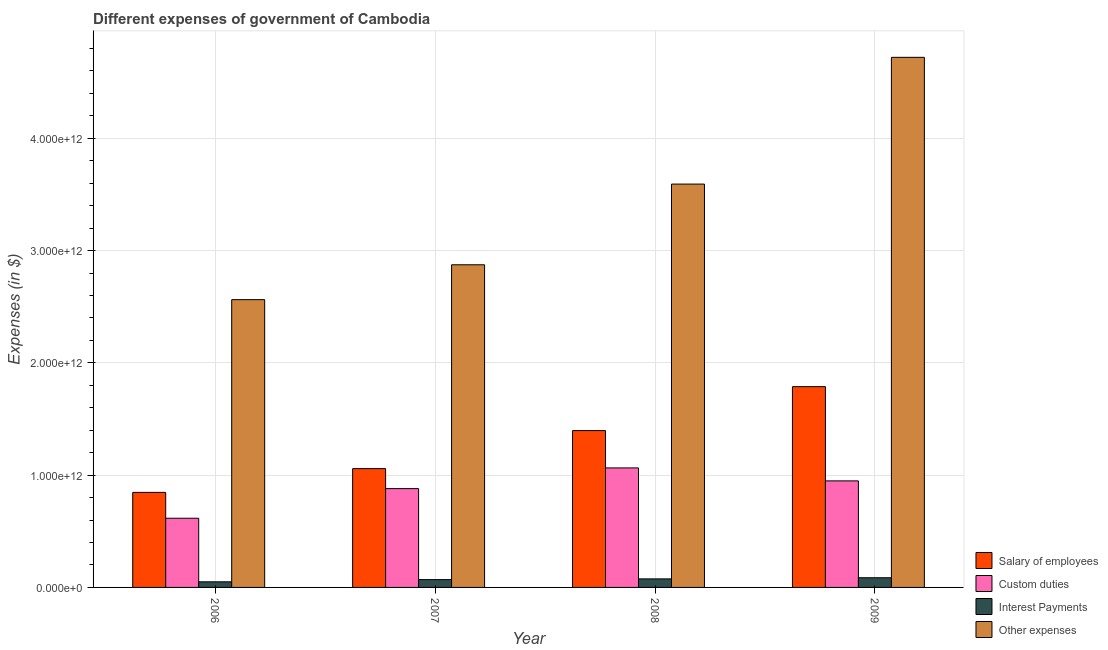How many groups of bars are there?
Your answer should be very brief. 4. Are the number of bars per tick equal to the number of legend labels?
Your answer should be very brief. Yes. Are the number of bars on each tick of the X-axis equal?
Your response must be concise. Yes. How many bars are there on the 1st tick from the right?
Offer a very short reply. 4. What is the label of the 1st group of bars from the left?
Your answer should be very brief. 2006. What is the amount spent on salary of employees in 2006?
Provide a short and direct response. 8.47e+11. Across all years, what is the maximum amount spent on interest payments?
Keep it short and to the point. 8.63e+1. Across all years, what is the minimum amount spent on interest payments?
Make the answer very short. 5.00e+1. In which year was the amount spent on custom duties maximum?
Ensure brevity in your answer.  2008. In which year was the amount spent on salary of employees minimum?
Offer a terse response. 2006. What is the total amount spent on interest payments in the graph?
Keep it short and to the point. 2.82e+11. What is the difference between the amount spent on salary of employees in 2006 and that in 2007?
Offer a very short reply. -2.12e+11. What is the difference between the amount spent on other expenses in 2009 and the amount spent on custom duties in 2006?
Give a very brief answer. 2.16e+12. What is the average amount spent on custom duties per year?
Give a very brief answer. 8.77e+11. What is the ratio of the amount spent on interest payments in 2007 to that in 2009?
Make the answer very short. 0.81. Is the amount spent on interest payments in 2006 less than that in 2009?
Your response must be concise. Yes. Is the difference between the amount spent on salary of employees in 2007 and 2009 greater than the difference between the amount spent on interest payments in 2007 and 2009?
Provide a short and direct response. No. What is the difference between the highest and the second highest amount spent on custom duties?
Keep it short and to the point. 1.15e+11. What is the difference between the highest and the lowest amount spent on custom duties?
Give a very brief answer. 4.48e+11. In how many years, is the amount spent on interest payments greater than the average amount spent on interest payments taken over all years?
Ensure brevity in your answer.  2. Is the sum of the amount spent on salary of employees in 2007 and 2008 greater than the maximum amount spent on custom duties across all years?
Ensure brevity in your answer.  Yes. What does the 2nd bar from the left in 2009 represents?
Keep it short and to the point. Custom duties. What does the 3rd bar from the right in 2008 represents?
Keep it short and to the point. Custom duties. How many bars are there?
Give a very brief answer. 16. How many years are there in the graph?
Keep it short and to the point. 4. What is the difference between two consecutive major ticks on the Y-axis?
Provide a succinct answer. 1.00e+12. Does the graph contain any zero values?
Ensure brevity in your answer.  No. Does the graph contain grids?
Give a very brief answer. Yes. What is the title of the graph?
Ensure brevity in your answer.  Different expenses of government of Cambodia. What is the label or title of the X-axis?
Provide a succinct answer. Year. What is the label or title of the Y-axis?
Offer a terse response. Expenses (in $). What is the Expenses (in $) of Salary of employees in 2006?
Ensure brevity in your answer.  8.47e+11. What is the Expenses (in $) in Custom duties in 2006?
Your answer should be compact. 6.16e+11. What is the Expenses (in $) in Interest Payments in 2006?
Give a very brief answer. 5.00e+1. What is the Expenses (in $) of Other expenses in 2006?
Your answer should be compact. 2.56e+12. What is the Expenses (in $) in Salary of employees in 2007?
Provide a short and direct response. 1.06e+12. What is the Expenses (in $) in Custom duties in 2007?
Make the answer very short. 8.80e+11. What is the Expenses (in $) in Interest Payments in 2007?
Offer a very short reply. 6.97e+1. What is the Expenses (in $) in Other expenses in 2007?
Make the answer very short. 2.87e+12. What is the Expenses (in $) of Salary of employees in 2008?
Ensure brevity in your answer.  1.40e+12. What is the Expenses (in $) in Custom duties in 2008?
Give a very brief answer. 1.06e+12. What is the Expenses (in $) of Interest Payments in 2008?
Ensure brevity in your answer.  7.61e+1. What is the Expenses (in $) of Other expenses in 2008?
Give a very brief answer. 3.59e+12. What is the Expenses (in $) in Salary of employees in 2009?
Your answer should be very brief. 1.79e+12. What is the Expenses (in $) in Custom duties in 2009?
Make the answer very short. 9.49e+11. What is the Expenses (in $) in Interest Payments in 2009?
Make the answer very short. 8.63e+1. What is the Expenses (in $) of Other expenses in 2009?
Offer a terse response. 4.72e+12. Across all years, what is the maximum Expenses (in $) of Salary of employees?
Make the answer very short. 1.79e+12. Across all years, what is the maximum Expenses (in $) in Custom duties?
Provide a short and direct response. 1.06e+12. Across all years, what is the maximum Expenses (in $) of Interest Payments?
Provide a short and direct response. 8.63e+1. Across all years, what is the maximum Expenses (in $) of Other expenses?
Provide a short and direct response. 4.72e+12. Across all years, what is the minimum Expenses (in $) in Salary of employees?
Offer a very short reply. 8.47e+11. Across all years, what is the minimum Expenses (in $) of Custom duties?
Keep it short and to the point. 6.16e+11. Across all years, what is the minimum Expenses (in $) in Interest Payments?
Your response must be concise. 5.00e+1. Across all years, what is the minimum Expenses (in $) in Other expenses?
Your answer should be compact. 2.56e+12. What is the total Expenses (in $) in Salary of employees in the graph?
Your answer should be compact. 5.09e+12. What is the total Expenses (in $) in Custom duties in the graph?
Give a very brief answer. 3.51e+12. What is the total Expenses (in $) in Interest Payments in the graph?
Offer a terse response. 2.82e+11. What is the total Expenses (in $) of Other expenses in the graph?
Offer a terse response. 1.38e+13. What is the difference between the Expenses (in $) of Salary of employees in 2006 and that in 2007?
Your answer should be compact. -2.12e+11. What is the difference between the Expenses (in $) of Custom duties in 2006 and that in 2007?
Provide a succinct answer. -2.64e+11. What is the difference between the Expenses (in $) of Interest Payments in 2006 and that in 2007?
Ensure brevity in your answer.  -1.97e+1. What is the difference between the Expenses (in $) of Other expenses in 2006 and that in 2007?
Your answer should be compact. -3.11e+11. What is the difference between the Expenses (in $) in Salary of employees in 2006 and that in 2008?
Provide a short and direct response. -5.50e+11. What is the difference between the Expenses (in $) in Custom duties in 2006 and that in 2008?
Offer a very short reply. -4.48e+11. What is the difference between the Expenses (in $) in Interest Payments in 2006 and that in 2008?
Offer a terse response. -2.61e+1. What is the difference between the Expenses (in $) of Other expenses in 2006 and that in 2008?
Provide a short and direct response. -1.03e+12. What is the difference between the Expenses (in $) of Salary of employees in 2006 and that in 2009?
Offer a very short reply. -9.42e+11. What is the difference between the Expenses (in $) of Custom duties in 2006 and that in 2009?
Provide a succinct answer. -3.33e+11. What is the difference between the Expenses (in $) of Interest Payments in 2006 and that in 2009?
Give a very brief answer. -3.63e+1. What is the difference between the Expenses (in $) in Other expenses in 2006 and that in 2009?
Provide a succinct answer. -2.16e+12. What is the difference between the Expenses (in $) of Salary of employees in 2007 and that in 2008?
Ensure brevity in your answer.  -3.39e+11. What is the difference between the Expenses (in $) of Custom duties in 2007 and that in 2008?
Keep it short and to the point. -1.84e+11. What is the difference between the Expenses (in $) in Interest Payments in 2007 and that in 2008?
Your answer should be very brief. -6.34e+09. What is the difference between the Expenses (in $) in Other expenses in 2007 and that in 2008?
Provide a succinct answer. -7.19e+11. What is the difference between the Expenses (in $) of Salary of employees in 2007 and that in 2009?
Ensure brevity in your answer.  -7.30e+11. What is the difference between the Expenses (in $) of Custom duties in 2007 and that in 2009?
Your answer should be very brief. -6.90e+1. What is the difference between the Expenses (in $) in Interest Payments in 2007 and that in 2009?
Offer a very short reply. -1.66e+1. What is the difference between the Expenses (in $) in Other expenses in 2007 and that in 2009?
Keep it short and to the point. -1.85e+12. What is the difference between the Expenses (in $) in Salary of employees in 2008 and that in 2009?
Give a very brief answer. -3.91e+11. What is the difference between the Expenses (in $) of Custom duties in 2008 and that in 2009?
Make the answer very short. 1.15e+11. What is the difference between the Expenses (in $) of Interest Payments in 2008 and that in 2009?
Offer a very short reply. -1.02e+1. What is the difference between the Expenses (in $) in Other expenses in 2008 and that in 2009?
Your answer should be compact. -1.13e+12. What is the difference between the Expenses (in $) of Salary of employees in 2006 and the Expenses (in $) of Custom duties in 2007?
Ensure brevity in your answer.  -3.35e+1. What is the difference between the Expenses (in $) of Salary of employees in 2006 and the Expenses (in $) of Interest Payments in 2007?
Provide a succinct answer. 7.77e+11. What is the difference between the Expenses (in $) of Salary of employees in 2006 and the Expenses (in $) of Other expenses in 2007?
Ensure brevity in your answer.  -2.03e+12. What is the difference between the Expenses (in $) of Custom duties in 2006 and the Expenses (in $) of Interest Payments in 2007?
Offer a terse response. 5.47e+11. What is the difference between the Expenses (in $) of Custom duties in 2006 and the Expenses (in $) of Other expenses in 2007?
Provide a succinct answer. -2.26e+12. What is the difference between the Expenses (in $) in Interest Payments in 2006 and the Expenses (in $) in Other expenses in 2007?
Offer a terse response. -2.82e+12. What is the difference between the Expenses (in $) in Salary of employees in 2006 and the Expenses (in $) in Custom duties in 2008?
Your answer should be compact. -2.18e+11. What is the difference between the Expenses (in $) of Salary of employees in 2006 and the Expenses (in $) of Interest Payments in 2008?
Ensure brevity in your answer.  7.71e+11. What is the difference between the Expenses (in $) of Salary of employees in 2006 and the Expenses (in $) of Other expenses in 2008?
Your answer should be compact. -2.75e+12. What is the difference between the Expenses (in $) of Custom duties in 2006 and the Expenses (in $) of Interest Payments in 2008?
Offer a terse response. 5.40e+11. What is the difference between the Expenses (in $) of Custom duties in 2006 and the Expenses (in $) of Other expenses in 2008?
Make the answer very short. -2.98e+12. What is the difference between the Expenses (in $) in Interest Payments in 2006 and the Expenses (in $) in Other expenses in 2008?
Offer a terse response. -3.54e+12. What is the difference between the Expenses (in $) in Salary of employees in 2006 and the Expenses (in $) in Custom duties in 2009?
Make the answer very short. -1.02e+11. What is the difference between the Expenses (in $) in Salary of employees in 2006 and the Expenses (in $) in Interest Payments in 2009?
Keep it short and to the point. 7.60e+11. What is the difference between the Expenses (in $) in Salary of employees in 2006 and the Expenses (in $) in Other expenses in 2009?
Ensure brevity in your answer.  -3.87e+12. What is the difference between the Expenses (in $) in Custom duties in 2006 and the Expenses (in $) in Interest Payments in 2009?
Ensure brevity in your answer.  5.30e+11. What is the difference between the Expenses (in $) of Custom duties in 2006 and the Expenses (in $) of Other expenses in 2009?
Offer a terse response. -4.11e+12. What is the difference between the Expenses (in $) in Interest Payments in 2006 and the Expenses (in $) in Other expenses in 2009?
Your answer should be very brief. -4.67e+12. What is the difference between the Expenses (in $) of Salary of employees in 2007 and the Expenses (in $) of Custom duties in 2008?
Offer a terse response. -6.22e+09. What is the difference between the Expenses (in $) in Salary of employees in 2007 and the Expenses (in $) in Interest Payments in 2008?
Offer a terse response. 9.82e+11. What is the difference between the Expenses (in $) in Salary of employees in 2007 and the Expenses (in $) in Other expenses in 2008?
Offer a very short reply. -2.53e+12. What is the difference between the Expenses (in $) of Custom duties in 2007 and the Expenses (in $) of Interest Payments in 2008?
Provide a short and direct response. 8.04e+11. What is the difference between the Expenses (in $) in Custom duties in 2007 and the Expenses (in $) in Other expenses in 2008?
Offer a terse response. -2.71e+12. What is the difference between the Expenses (in $) in Interest Payments in 2007 and the Expenses (in $) in Other expenses in 2008?
Make the answer very short. -3.52e+12. What is the difference between the Expenses (in $) in Salary of employees in 2007 and the Expenses (in $) in Custom duties in 2009?
Ensure brevity in your answer.  1.09e+11. What is the difference between the Expenses (in $) in Salary of employees in 2007 and the Expenses (in $) in Interest Payments in 2009?
Ensure brevity in your answer.  9.72e+11. What is the difference between the Expenses (in $) of Salary of employees in 2007 and the Expenses (in $) of Other expenses in 2009?
Your answer should be compact. -3.66e+12. What is the difference between the Expenses (in $) of Custom duties in 2007 and the Expenses (in $) of Interest Payments in 2009?
Provide a short and direct response. 7.94e+11. What is the difference between the Expenses (in $) in Custom duties in 2007 and the Expenses (in $) in Other expenses in 2009?
Make the answer very short. -3.84e+12. What is the difference between the Expenses (in $) in Interest Payments in 2007 and the Expenses (in $) in Other expenses in 2009?
Give a very brief answer. -4.65e+12. What is the difference between the Expenses (in $) of Salary of employees in 2008 and the Expenses (in $) of Custom duties in 2009?
Keep it short and to the point. 4.48e+11. What is the difference between the Expenses (in $) of Salary of employees in 2008 and the Expenses (in $) of Interest Payments in 2009?
Your answer should be compact. 1.31e+12. What is the difference between the Expenses (in $) of Salary of employees in 2008 and the Expenses (in $) of Other expenses in 2009?
Provide a succinct answer. -3.32e+12. What is the difference between the Expenses (in $) of Custom duties in 2008 and the Expenses (in $) of Interest Payments in 2009?
Keep it short and to the point. 9.78e+11. What is the difference between the Expenses (in $) of Custom duties in 2008 and the Expenses (in $) of Other expenses in 2009?
Your response must be concise. -3.66e+12. What is the difference between the Expenses (in $) of Interest Payments in 2008 and the Expenses (in $) of Other expenses in 2009?
Offer a very short reply. -4.65e+12. What is the average Expenses (in $) in Salary of employees per year?
Your answer should be very brief. 1.27e+12. What is the average Expenses (in $) in Custom duties per year?
Your response must be concise. 8.77e+11. What is the average Expenses (in $) in Interest Payments per year?
Offer a very short reply. 7.05e+1. What is the average Expenses (in $) in Other expenses per year?
Provide a short and direct response. 3.44e+12. In the year 2006, what is the difference between the Expenses (in $) in Salary of employees and Expenses (in $) in Custom duties?
Your response must be concise. 2.30e+11. In the year 2006, what is the difference between the Expenses (in $) in Salary of employees and Expenses (in $) in Interest Payments?
Your answer should be very brief. 7.97e+11. In the year 2006, what is the difference between the Expenses (in $) in Salary of employees and Expenses (in $) in Other expenses?
Offer a terse response. -1.72e+12. In the year 2006, what is the difference between the Expenses (in $) in Custom duties and Expenses (in $) in Interest Payments?
Provide a succinct answer. 5.66e+11. In the year 2006, what is the difference between the Expenses (in $) in Custom duties and Expenses (in $) in Other expenses?
Provide a succinct answer. -1.95e+12. In the year 2006, what is the difference between the Expenses (in $) of Interest Payments and Expenses (in $) of Other expenses?
Your response must be concise. -2.51e+12. In the year 2007, what is the difference between the Expenses (in $) in Salary of employees and Expenses (in $) in Custom duties?
Your answer should be compact. 1.78e+11. In the year 2007, what is the difference between the Expenses (in $) of Salary of employees and Expenses (in $) of Interest Payments?
Ensure brevity in your answer.  9.88e+11. In the year 2007, what is the difference between the Expenses (in $) in Salary of employees and Expenses (in $) in Other expenses?
Your response must be concise. -1.82e+12. In the year 2007, what is the difference between the Expenses (in $) in Custom duties and Expenses (in $) in Interest Payments?
Your response must be concise. 8.10e+11. In the year 2007, what is the difference between the Expenses (in $) in Custom duties and Expenses (in $) in Other expenses?
Give a very brief answer. -1.99e+12. In the year 2007, what is the difference between the Expenses (in $) of Interest Payments and Expenses (in $) of Other expenses?
Your answer should be compact. -2.80e+12. In the year 2008, what is the difference between the Expenses (in $) of Salary of employees and Expenses (in $) of Custom duties?
Your response must be concise. 3.32e+11. In the year 2008, what is the difference between the Expenses (in $) of Salary of employees and Expenses (in $) of Interest Payments?
Give a very brief answer. 1.32e+12. In the year 2008, what is the difference between the Expenses (in $) in Salary of employees and Expenses (in $) in Other expenses?
Offer a very short reply. -2.20e+12. In the year 2008, what is the difference between the Expenses (in $) of Custom duties and Expenses (in $) of Interest Payments?
Offer a terse response. 9.88e+11. In the year 2008, what is the difference between the Expenses (in $) in Custom duties and Expenses (in $) in Other expenses?
Your answer should be very brief. -2.53e+12. In the year 2008, what is the difference between the Expenses (in $) in Interest Payments and Expenses (in $) in Other expenses?
Give a very brief answer. -3.52e+12. In the year 2009, what is the difference between the Expenses (in $) in Salary of employees and Expenses (in $) in Custom duties?
Your answer should be compact. 8.39e+11. In the year 2009, what is the difference between the Expenses (in $) in Salary of employees and Expenses (in $) in Interest Payments?
Give a very brief answer. 1.70e+12. In the year 2009, what is the difference between the Expenses (in $) in Salary of employees and Expenses (in $) in Other expenses?
Keep it short and to the point. -2.93e+12. In the year 2009, what is the difference between the Expenses (in $) in Custom duties and Expenses (in $) in Interest Payments?
Ensure brevity in your answer.  8.63e+11. In the year 2009, what is the difference between the Expenses (in $) of Custom duties and Expenses (in $) of Other expenses?
Your answer should be compact. -3.77e+12. In the year 2009, what is the difference between the Expenses (in $) in Interest Payments and Expenses (in $) in Other expenses?
Offer a very short reply. -4.64e+12. What is the ratio of the Expenses (in $) in Salary of employees in 2006 to that in 2007?
Your answer should be very brief. 0.8. What is the ratio of the Expenses (in $) in Custom duties in 2006 to that in 2007?
Give a very brief answer. 0.7. What is the ratio of the Expenses (in $) of Interest Payments in 2006 to that in 2007?
Offer a terse response. 0.72. What is the ratio of the Expenses (in $) in Other expenses in 2006 to that in 2007?
Keep it short and to the point. 0.89. What is the ratio of the Expenses (in $) of Salary of employees in 2006 to that in 2008?
Your answer should be very brief. 0.61. What is the ratio of the Expenses (in $) in Custom duties in 2006 to that in 2008?
Your answer should be compact. 0.58. What is the ratio of the Expenses (in $) of Interest Payments in 2006 to that in 2008?
Keep it short and to the point. 0.66. What is the ratio of the Expenses (in $) in Other expenses in 2006 to that in 2008?
Your answer should be very brief. 0.71. What is the ratio of the Expenses (in $) of Salary of employees in 2006 to that in 2009?
Give a very brief answer. 0.47. What is the ratio of the Expenses (in $) of Custom duties in 2006 to that in 2009?
Make the answer very short. 0.65. What is the ratio of the Expenses (in $) of Interest Payments in 2006 to that in 2009?
Your answer should be very brief. 0.58. What is the ratio of the Expenses (in $) of Other expenses in 2006 to that in 2009?
Provide a succinct answer. 0.54. What is the ratio of the Expenses (in $) in Salary of employees in 2007 to that in 2008?
Ensure brevity in your answer.  0.76. What is the ratio of the Expenses (in $) in Custom duties in 2007 to that in 2008?
Ensure brevity in your answer.  0.83. What is the ratio of the Expenses (in $) in Interest Payments in 2007 to that in 2008?
Your response must be concise. 0.92. What is the ratio of the Expenses (in $) of Salary of employees in 2007 to that in 2009?
Your response must be concise. 0.59. What is the ratio of the Expenses (in $) in Custom duties in 2007 to that in 2009?
Ensure brevity in your answer.  0.93. What is the ratio of the Expenses (in $) of Interest Payments in 2007 to that in 2009?
Your answer should be very brief. 0.81. What is the ratio of the Expenses (in $) of Other expenses in 2007 to that in 2009?
Keep it short and to the point. 0.61. What is the ratio of the Expenses (in $) in Salary of employees in 2008 to that in 2009?
Provide a short and direct response. 0.78. What is the ratio of the Expenses (in $) of Custom duties in 2008 to that in 2009?
Your response must be concise. 1.12. What is the ratio of the Expenses (in $) in Interest Payments in 2008 to that in 2009?
Offer a very short reply. 0.88. What is the ratio of the Expenses (in $) in Other expenses in 2008 to that in 2009?
Give a very brief answer. 0.76. What is the difference between the highest and the second highest Expenses (in $) of Salary of employees?
Offer a terse response. 3.91e+11. What is the difference between the highest and the second highest Expenses (in $) in Custom duties?
Keep it short and to the point. 1.15e+11. What is the difference between the highest and the second highest Expenses (in $) in Interest Payments?
Keep it short and to the point. 1.02e+1. What is the difference between the highest and the second highest Expenses (in $) of Other expenses?
Keep it short and to the point. 1.13e+12. What is the difference between the highest and the lowest Expenses (in $) in Salary of employees?
Provide a short and direct response. 9.42e+11. What is the difference between the highest and the lowest Expenses (in $) in Custom duties?
Ensure brevity in your answer.  4.48e+11. What is the difference between the highest and the lowest Expenses (in $) of Interest Payments?
Provide a short and direct response. 3.63e+1. What is the difference between the highest and the lowest Expenses (in $) of Other expenses?
Make the answer very short. 2.16e+12. 